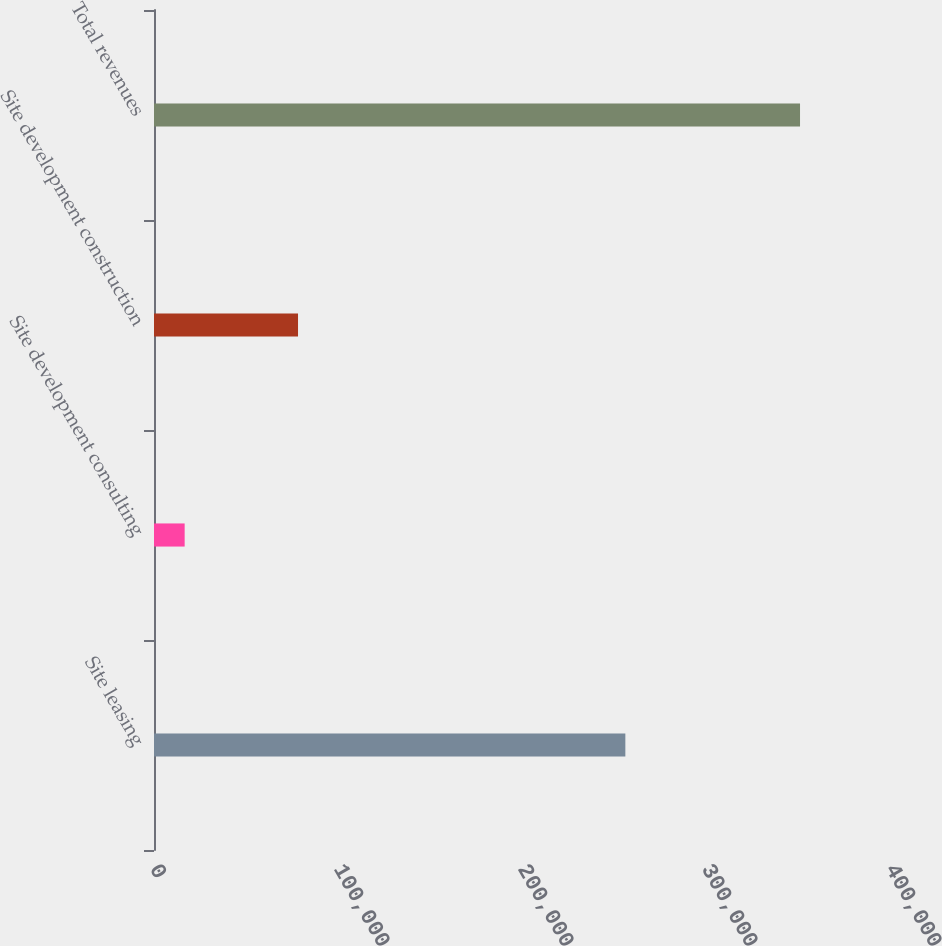Convert chart to OTSL. <chart><loc_0><loc_0><loc_500><loc_500><bar_chart><fcel>Site leasing<fcel>Site development consulting<fcel>Site development construction<fcel>Total revenues<nl><fcel>256170<fcel>16660<fcel>78272<fcel>351102<nl></chart> 